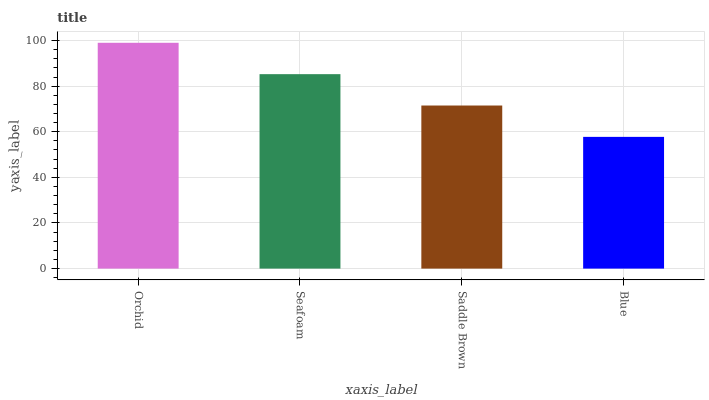Is Seafoam the minimum?
Answer yes or no. No. Is Seafoam the maximum?
Answer yes or no. No. Is Orchid greater than Seafoam?
Answer yes or no. Yes. Is Seafoam less than Orchid?
Answer yes or no. Yes. Is Seafoam greater than Orchid?
Answer yes or no. No. Is Orchid less than Seafoam?
Answer yes or no. No. Is Seafoam the high median?
Answer yes or no. Yes. Is Saddle Brown the low median?
Answer yes or no. Yes. Is Blue the high median?
Answer yes or no. No. Is Orchid the low median?
Answer yes or no. No. 